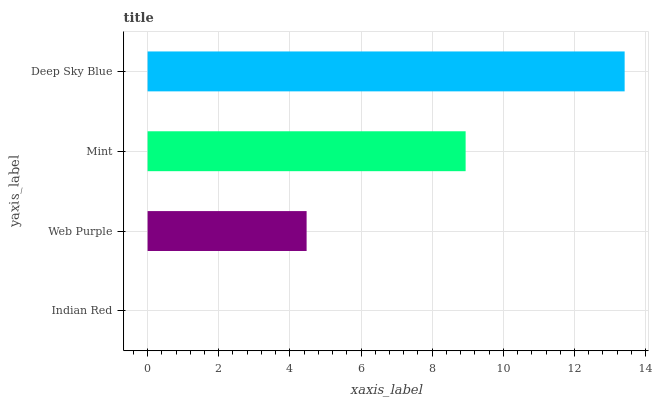Is Indian Red the minimum?
Answer yes or no. Yes. Is Deep Sky Blue the maximum?
Answer yes or no. Yes. Is Web Purple the minimum?
Answer yes or no. No. Is Web Purple the maximum?
Answer yes or no. No. Is Web Purple greater than Indian Red?
Answer yes or no. Yes. Is Indian Red less than Web Purple?
Answer yes or no. Yes. Is Indian Red greater than Web Purple?
Answer yes or no. No. Is Web Purple less than Indian Red?
Answer yes or no. No. Is Mint the high median?
Answer yes or no. Yes. Is Web Purple the low median?
Answer yes or no. Yes. Is Deep Sky Blue the high median?
Answer yes or no. No. Is Indian Red the low median?
Answer yes or no. No. 